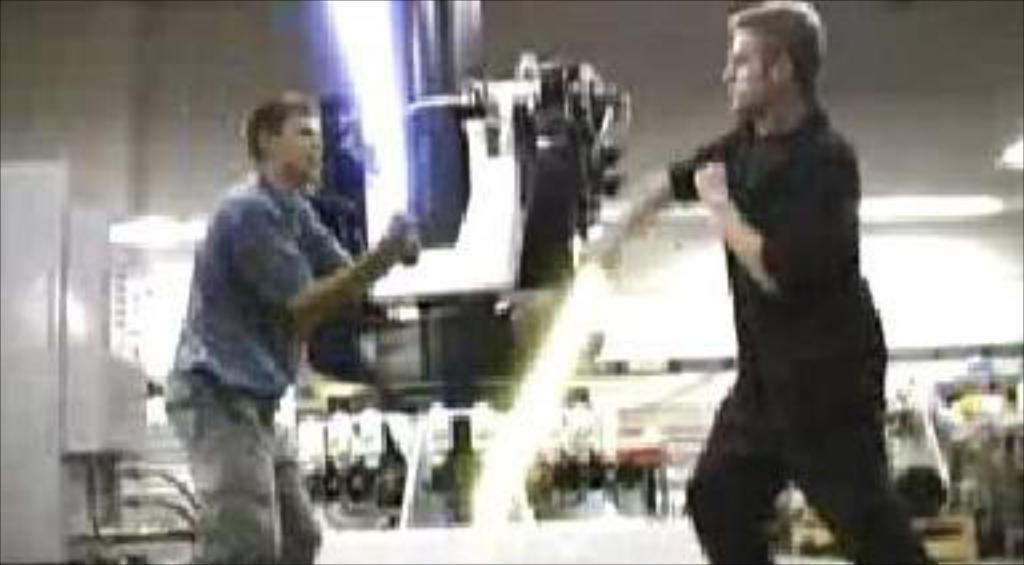What type of living organisms can be seen in the image? Men can be seen in the image. What is the primary surface on which the men are standing? The men are standing on the ground. What type of meal is being prepared by the men in the image? There is no indication in the image that the men are preparing a meal, as they are simply standing on the ground. Can you describe the weather conditions in the image? The provided facts do not mention any weather conditions, so it is not possible to determine the weather from the image. 